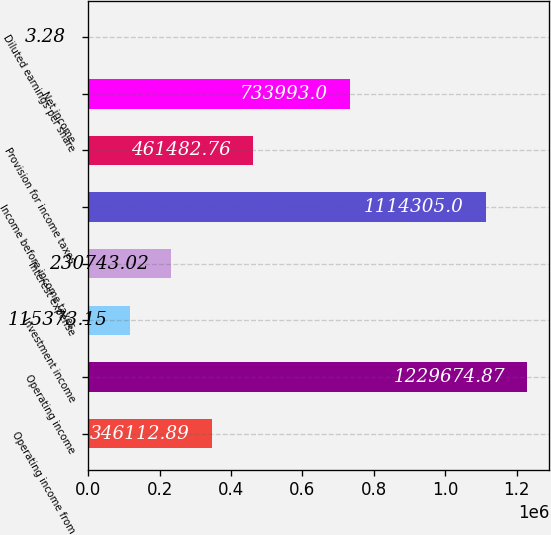Convert chart to OTSL. <chart><loc_0><loc_0><loc_500><loc_500><bar_chart><fcel>Operating income from<fcel>Operating income<fcel>Investment income<fcel>Interest expense<fcel>Income before income taxes<fcel>Provision for income taxes<fcel>Net income<fcel>Diluted earnings per share<nl><fcel>346113<fcel>1.22967e+06<fcel>115373<fcel>230743<fcel>1.1143e+06<fcel>461483<fcel>733993<fcel>3.28<nl></chart> 